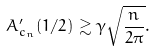<formula> <loc_0><loc_0><loc_500><loc_500>A _ { c _ { n } } ^ { \prime } ( 1 / 2 ) \gtrsim \gamma \sqrt { \frac { n } { 2 \pi } } .</formula> 